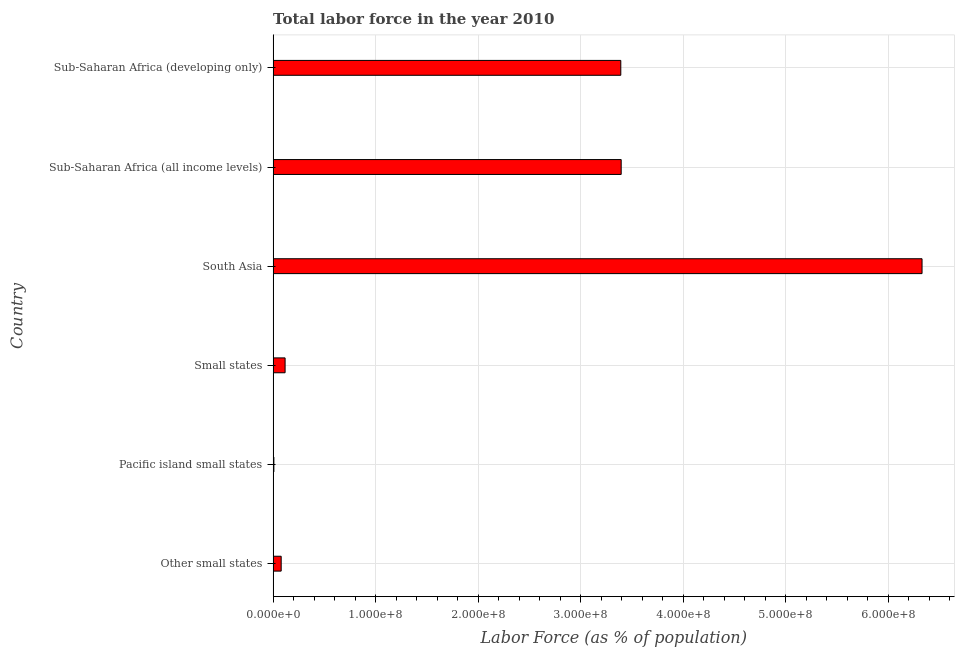What is the title of the graph?
Give a very brief answer. Total labor force in the year 2010. What is the label or title of the X-axis?
Ensure brevity in your answer.  Labor Force (as % of population). What is the label or title of the Y-axis?
Make the answer very short. Country. What is the total labor force in Sub-Saharan Africa (developing only)?
Provide a short and direct response. 3.39e+08. Across all countries, what is the maximum total labor force?
Keep it short and to the point. 6.33e+08. Across all countries, what is the minimum total labor force?
Provide a short and direct response. 7.38e+05. In which country was the total labor force maximum?
Offer a very short reply. South Asia. In which country was the total labor force minimum?
Your answer should be compact. Pacific island small states. What is the sum of the total labor force?
Your answer should be very brief. 1.33e+09. What is the difference between the total labor force in Other small states and Pacific island small states?
Ensure brevity in your answer.  7.13e+06. What is the average total labor force per country?
Provide a short and direct response. 2.22e+08. What is the median total labor force?
Offer a terse response. 1.75e+08. In how many countries, is the total labor force greater than 600000000 %?
Provide a short and direct response. 1. What is the ratio of the total labor force in Pacific island small states to that in Small states?
Your answer should be very brief. 0.06. Is the total labor force in Sub-Saharan Africa (all income levels) less than that in Sub-Saharan Africa (developing only)?
Offer a very short reply. No. What is the difference between the highest and the second highest total labor force?
Provide a short and direct response. 2.93e+08. What is the difference between the highest and the lowest total labor force?
Offer a very short reply. 6.32e+08. In how many countries, is the total labor force greater than the average total labor force taken over all countries?
Give a very brief answer. 3. Are all the bars in the graph horizontal?
Your response must be concise. Yes. How many countries are there in the graph?
Provide a short and direct response. 6. Are the values on the major ticks of X-axis written in scientific E-notation?
Provide a short and direct response. Yes. What is the Labor Force (as % of population) in Other small states?
Offer a terse response. 7.87e+06. What is the Labor Force (as % of population) in Pacific island small states?
Your response must be concise. 7.38e+05. What is the Labor Force (as % of population) in Small states?
Your response must be concise. 1.17e+07. What is the Labor Force (as % of population) in South Asia?
Provide a short and direct response. 6.33e+08. What is the Labor Force (as % of population) of Sub-Saharan Africa (all income levels)?
Your answer should be compact. 3.39e+08. What is the Labor Force (as % of population) of Sub-Saharan Africa (developing only)?
Your answer should be compact. 3.39e+08. What is the difference between the Labor Force (as % of population) in Other small states and Pacific island small states?
Offer a very short reply. 7.13e+06. What is the difference between the Labor Force (as % of population) in Other small states and Small states?
Keep it short and to the point. -3.81e+06. What is the difference between the Labor Force (as % of population) in Other small states and South Asia?
Offer a very short reply. -6.25e+08. What is the difference between the Labor Force (as % of population) in Other small states and Sub-Saharan Africa (all income levels)?
Your answer should be compact. -3.32e+08. What is the difference between the Labor Force (as % of population) in Other small states and Sub-Saharan Africa (developing only)?
Give a very brief answer. -3.31e+08. What is the difference between the Labor Force (as % of population) in Pacific island small states and Small states?
Provide a succinct answer. -1.09e+07. What is the difference between the Labor Force (as % of population) in Pacific island small states and South Asia?
Make the answer very short. -6.32e+08. What is the difference between the Labor Force (as % of population) in Pacific island small states and Sub-Saharan Africa (all income levels)?
Ensure brevity in your answer.  -3.39e+08. What is the difference between the Labor Force (as % of population) in Pacific island small states and Sub-Saharan Africa (developing only)?
Offer a terse response. -3.38e+08. What is the difference between the Labor Force (as % of population) in Small states and South Asia?
Keep it short and to the point. -6.21e+08. What is the difference between the Labor Force (as % of population) in Small states and Sub-Saharan Africa (all income levels)?
Provide a short and direct response. -3.28e+08. What is the difference between the Labor Force (as % of population) in Small states and Sub-Saharan Africa (developing only)?
Provide a short and direct response. -3.27e+08. What is the difference between the Labor Force (as % of population) in South Asia and Sub-Saharan Africa (all income levels)?
Make the answer very short. 2.93e+08. What is the difference between the Labor Force (as % of population) in South Asia and Sub-Saharan Africa (developing only)?
Ensure brevity in your answer.  2.94e+08. What is the difference between the Labor Force (as % of population) in Sub-Saharan Africa (all income levels) and Sub-Saharan Africa (developing only)?
Ensure brevity in your answer.  3.79e+05. What is the ratio of the Labor Force (as % of population) in Other small states to that in Pacific island small states?
Give a very brief answer. 10.66. What is the ratio of the Labor Force (as % of population) in Other small states to that in Small states?
Your response must be concise. 0.67. What is the ratio of the Labor Force (as % of population) in Other small states to that in South Asia?
Ensure brevity in your answer.  0.01. What is the ratio of the Labor Force (as % of population) in Other small states to that in Sub-Saharan Africa (all income levels)?
Make the answer very short. 0.02. What is the ratio of the Labor Force (as % of population) in Other small states to that in Sub-Saharan Africa (developing only)?
Keep it short and to the point. 0.02. What is the ratio of the Labor Force (as % of population) in Pacific island small states to that in Small states?
Your answer should be compact. 0.06. What is the ratio of the Labor Force (as % of population) in Pacific island small states to that in Sub-Saharan Africa (all income levels)?
Your answer should be very brief. 0. What is the ratio of the Labor Force (as % of population) in Pacific island small states to that in Sub-Saharan Africa (developing only)?
Make the answer very short. 0. What is the ratio of the Labor Force (as % of population) in Small states to that in South Asia?
Make the answer very short. 0.02. What is the ratio of the Labor Force (as % of population) in Small states to that in Sub-Saharan Africa (all income levels)?
Keep it short and to the point. 0.03. What is the ratio of the Labor Force (as % of population) in Small states to that in Sub-Saharan Africa (developing only)?
Keep it short and to the point. 0.03. What is the ratio of the Labor Force (as % of population) in South Asia to that in Sub-Saharan Africa (all income levels)?
Your response must be concise. 1.86. What is the ratio of the Labor Force (as % of population) in South Asia to that in Sub-Saharan Africa (developing only)?
Provide a succinct answer. 1.87. 